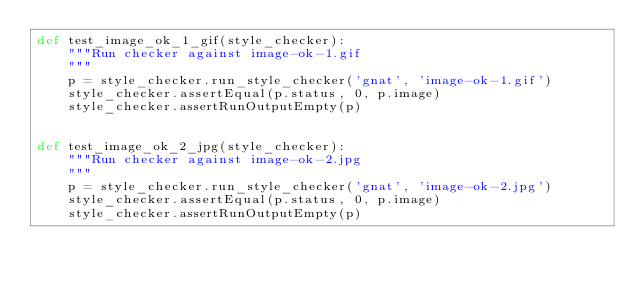Convert code to text. <code><loc_0><loc_0><loc_500><loc_500><_Python_>def test_image_ok_1_gif(style_checker):
    """Run checker against image-ok-1.gif
    """
    p = style_checker.run_style_checker('gnat', 'image-ok-1.gif')
    style_checker.assertEqual(p.status, 0, p.image)
    style_checker.assertRunOutputEmpty(p)


def test_image_ok_2_jpg(style_checker):
    """Run checker against image-ok-2.jpg
    """
    p = style_checker.run_style_checker('gnat', 'image-ok-2.jpg')
    style_checker.assertEqual(p.status, 0, p.image)
    style_checker.assertRunOutputEmpty(p)
</code> 